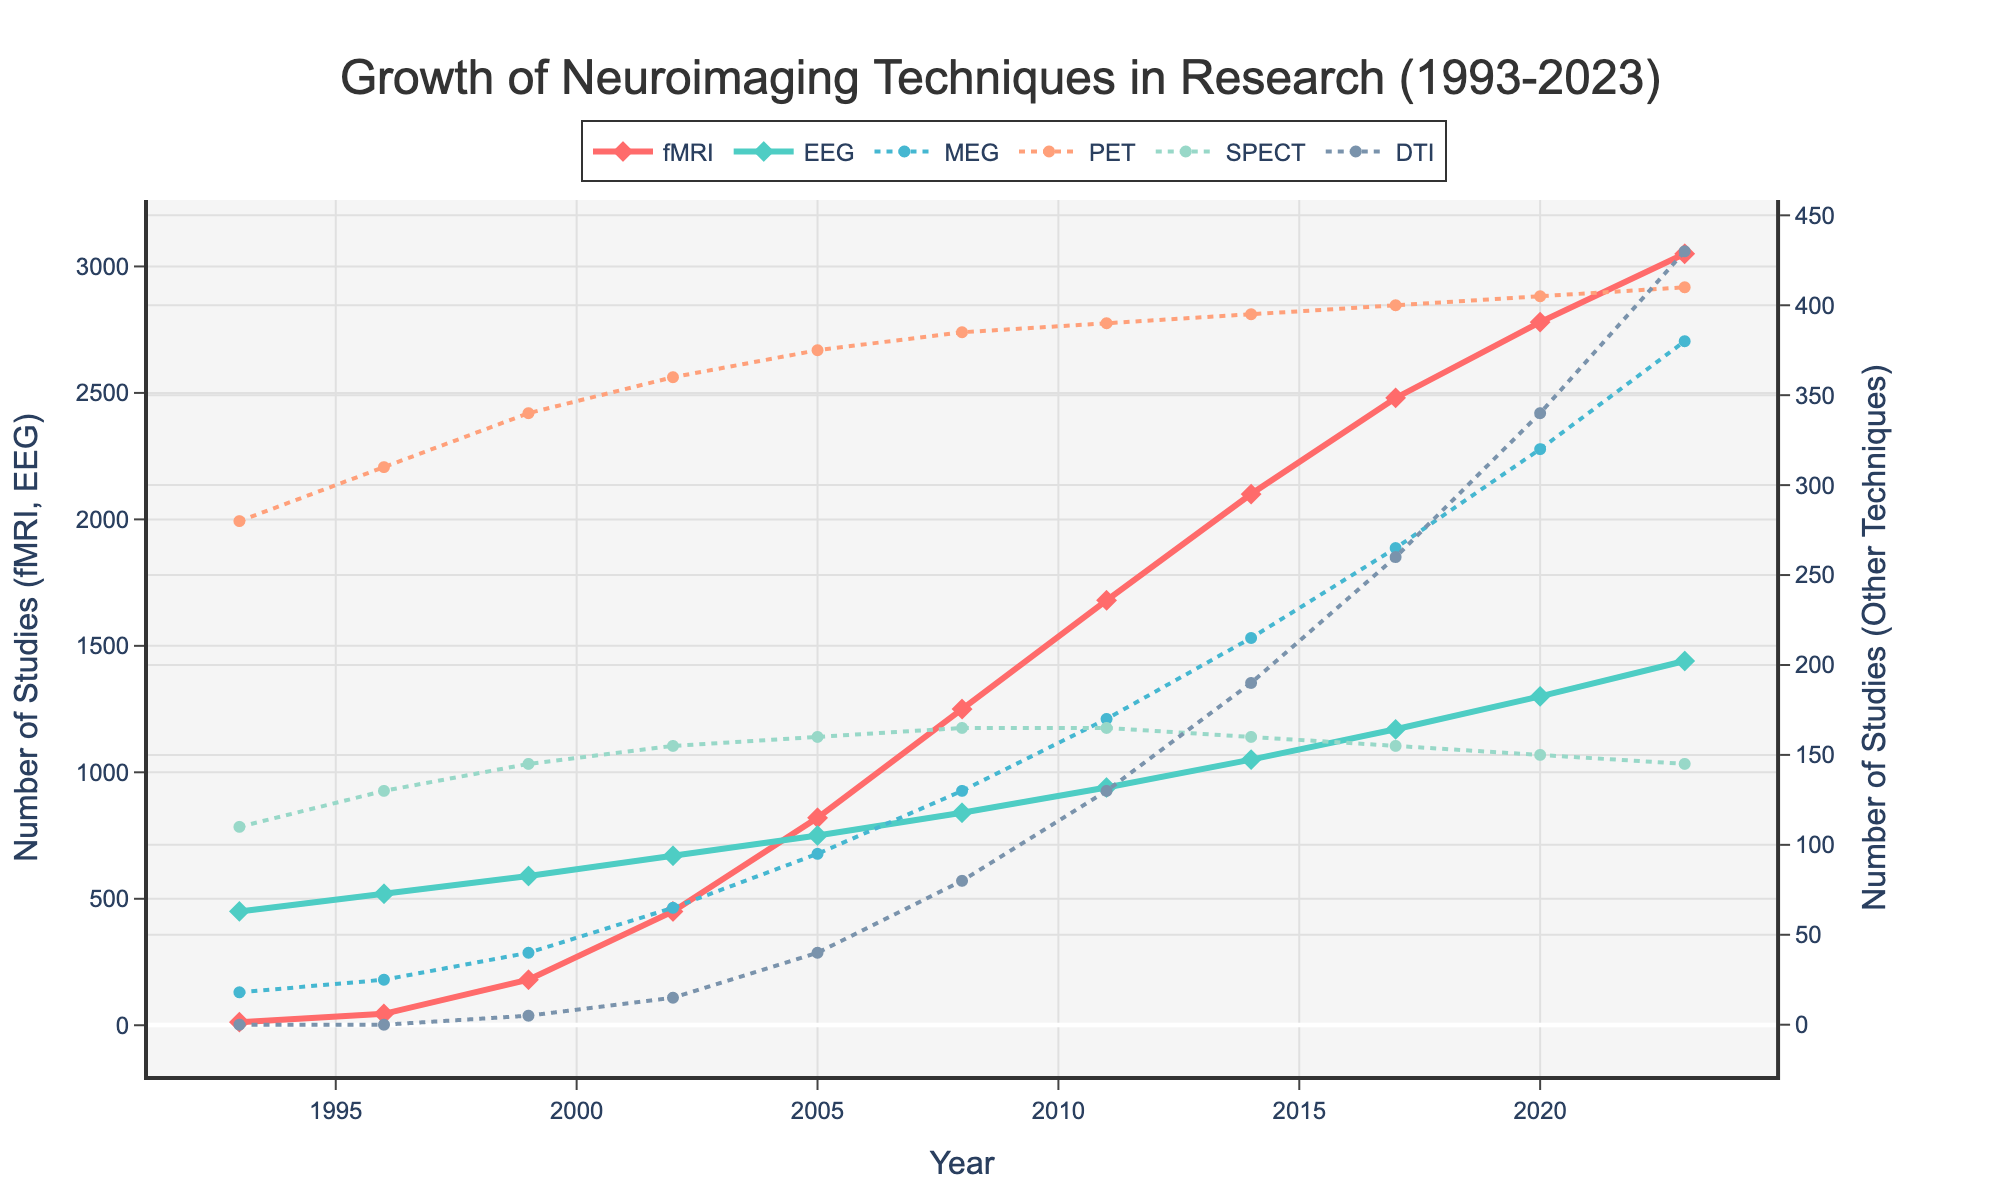How does the growth of fMRI usage compare to that of EEG from 1993 to 2023? To find how the growth of fMRI usage compares to that of EEG, observe their values in 1993 and 2023. In 1993, the fMRI usage was 12 and increased to 3050 by 2023. The EEG usage started at 450 in 1993 and went to 1440 in 2023. The growth for fMRI (3050 - 12 = 3038) is much higher compared to EEG (1440 - 450 = 990).
Answer: fMRI growth is much higher Which neuroimaging technique shows the most substantial growth over the past 30 years? This can be determined by comparing the differences in usage from 1993 to 2023 for each technique. The largest difference is observed for fMRI, which increased from 12 in 1993 to 3050 in 2023, showing a growth of 3038 studies.
Answer: fMRI By how much did the usage of DTI increase between 2002 and 2020? Identify the usage of DTI in 2002 (15) and in 2020 (340). The increase is calculated by subtracting the 2002 value from the 2020 value: 340 - 15 = 325.
Answer: 325 Between which two consecutive years does fMRI show the highest increase in usage? Examine the fMRI values for consecutive years and find the year pair with the maximum difference. The largest increase is between 1999 (180) and 2002 (450), which is an increase of 270.
Answer: 1999-2002 Which year shows a decrease in the usage of any technique? Specify the technique and the decrease. Identify any technique where the value decreases from one year to the next. The usage of SPECT decreases from 165 in 2011 to 160 in 2014, a decrease of 5.
Answer: SPECT, 2011-2014, 5 What is the average growth of MEG usage over each subsequent year from 1993 to 2023? Calculate the mean annual growth by finding the increase over these 30 years and then dividing by the number of intervals (2023-1993=30 years). MEG goes from 18 to 380 (increase by 362), so the average annual growth is 362/30 = about 12.07.
Answer: about 12.07 If the trends continue, estimate the number of studies using fMRI in 2026. Using the rate of increase observed in recent years, find the average annual increase from, say, 2017 to 2023. fMRI increases from 2480 in 2017 to 3050 in 2023 (570 increase over 6 years), giving an average annual increase of 570/6 = 95. Adding this to the 2023 value gives an estimate for 2026: 3050 + (3*95) = 3335.
Answer: 3335 What is the difference in usage between the most and least used technique in 2023? Identify the most-used (fMRI: 3050) and least-used (SPECT: 145) techniques in 2023. Subtract the least used from the most used: 3050 - 145 = 2905.
Answer: 2905 In which year did EEG surpass 1000 studies, and by how much did it surpass the 1000 mark? Find the first year where EEG usage exceeds 1000. In 2014, EEG usage reached 1050, surpassing 1000 by 50 studies.
Answer: 2014, by 50 studies Which technique had the most stable (least variable) growth, and how can this stability be observed? Examine the visually 'flattest' (least upward trending) line plots. PET shows the most stable growth, as it maintains relatively constant usage with small variations over the years.
Answer: PET 